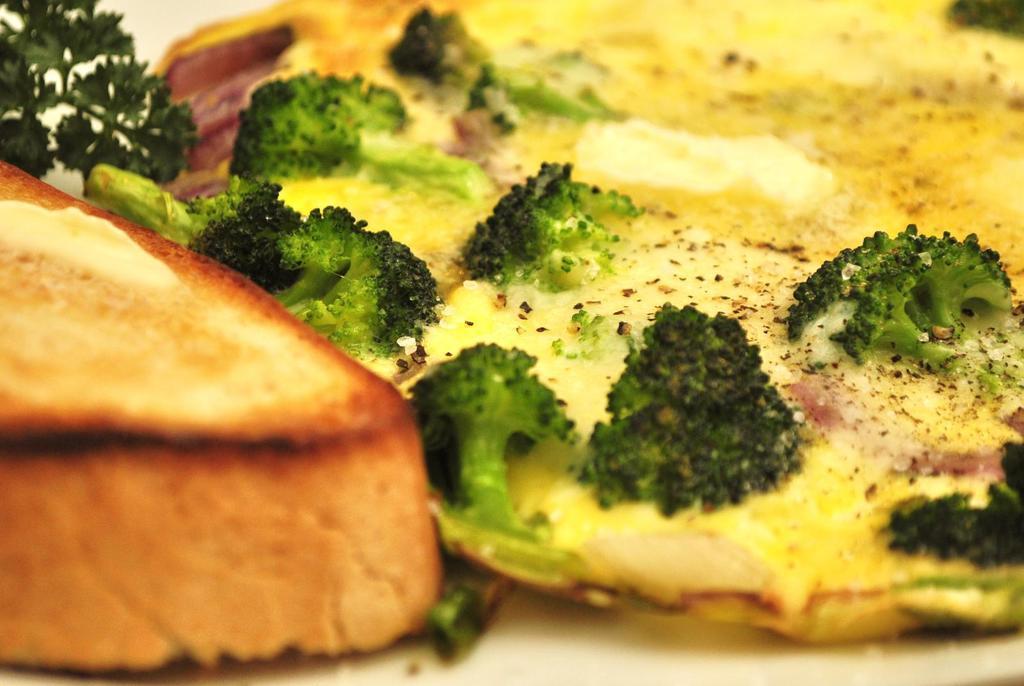In one or two sentences, can you explain what this image depicts? In this picture we can see omelet, bread, cabbage and mint on the tray. 